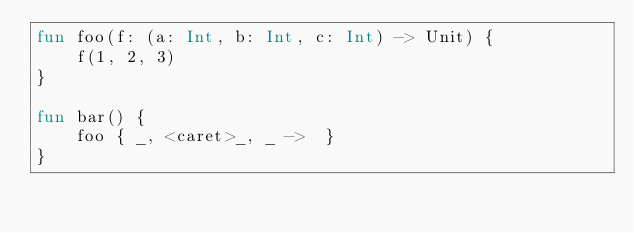<code> <loc_0><loc_0><loc_500><loc_500><_Kotlin_>fun foo(f: (a: Int, b: Int, c: Int) -> Unit) {
    f(1, 2, 3)
}

fun bar() {
    foo { _, <caret>_, _ ->  }
}
</code> 